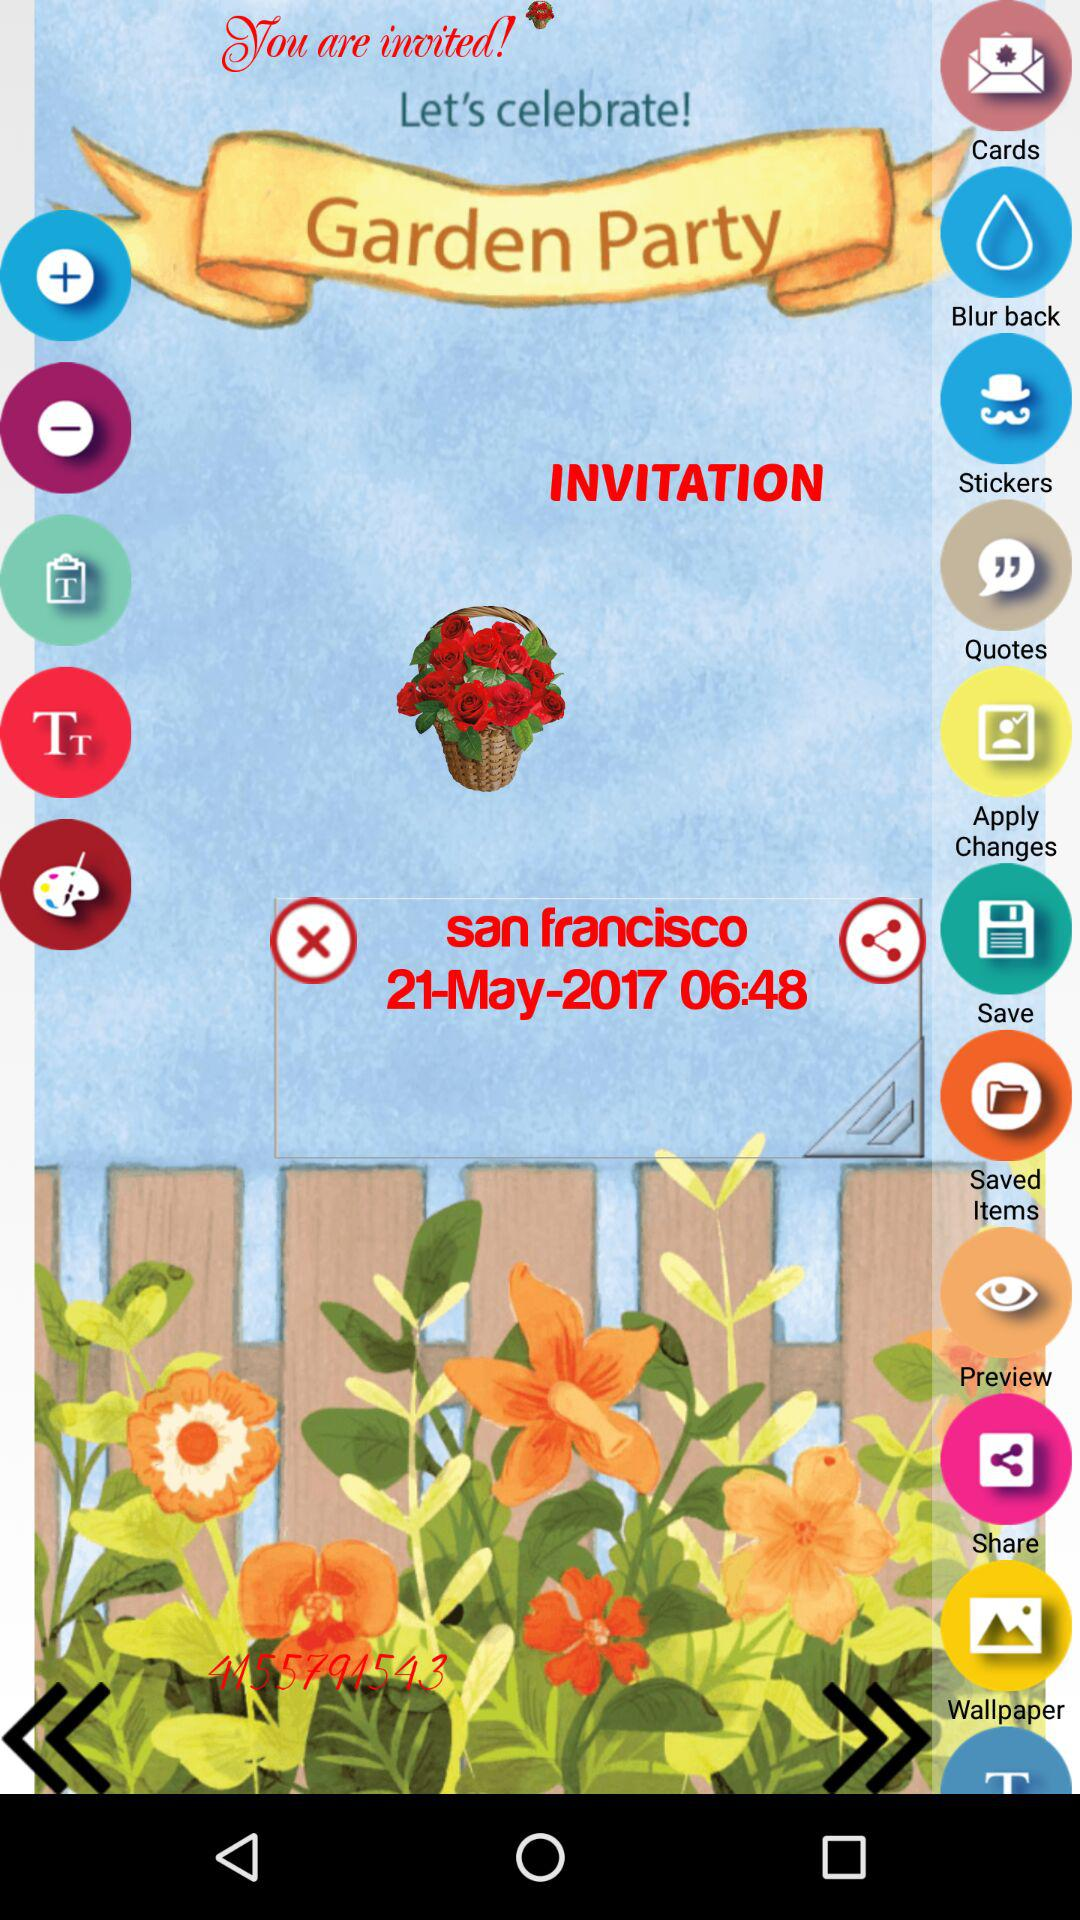What is the date of the party? The date of the party is May 21, 2017. 